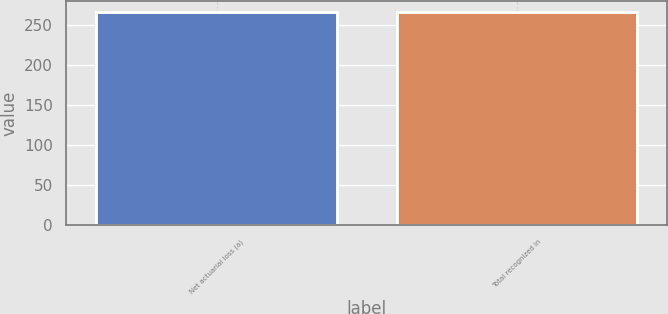<chart> <loc_0><loc_0><loc_500><loc_500><bar_chart><fcel>Net actuarial loss (a)<fcel>Total recognized in<nl><fcel>266<fcel>266.1<nl></chart> 